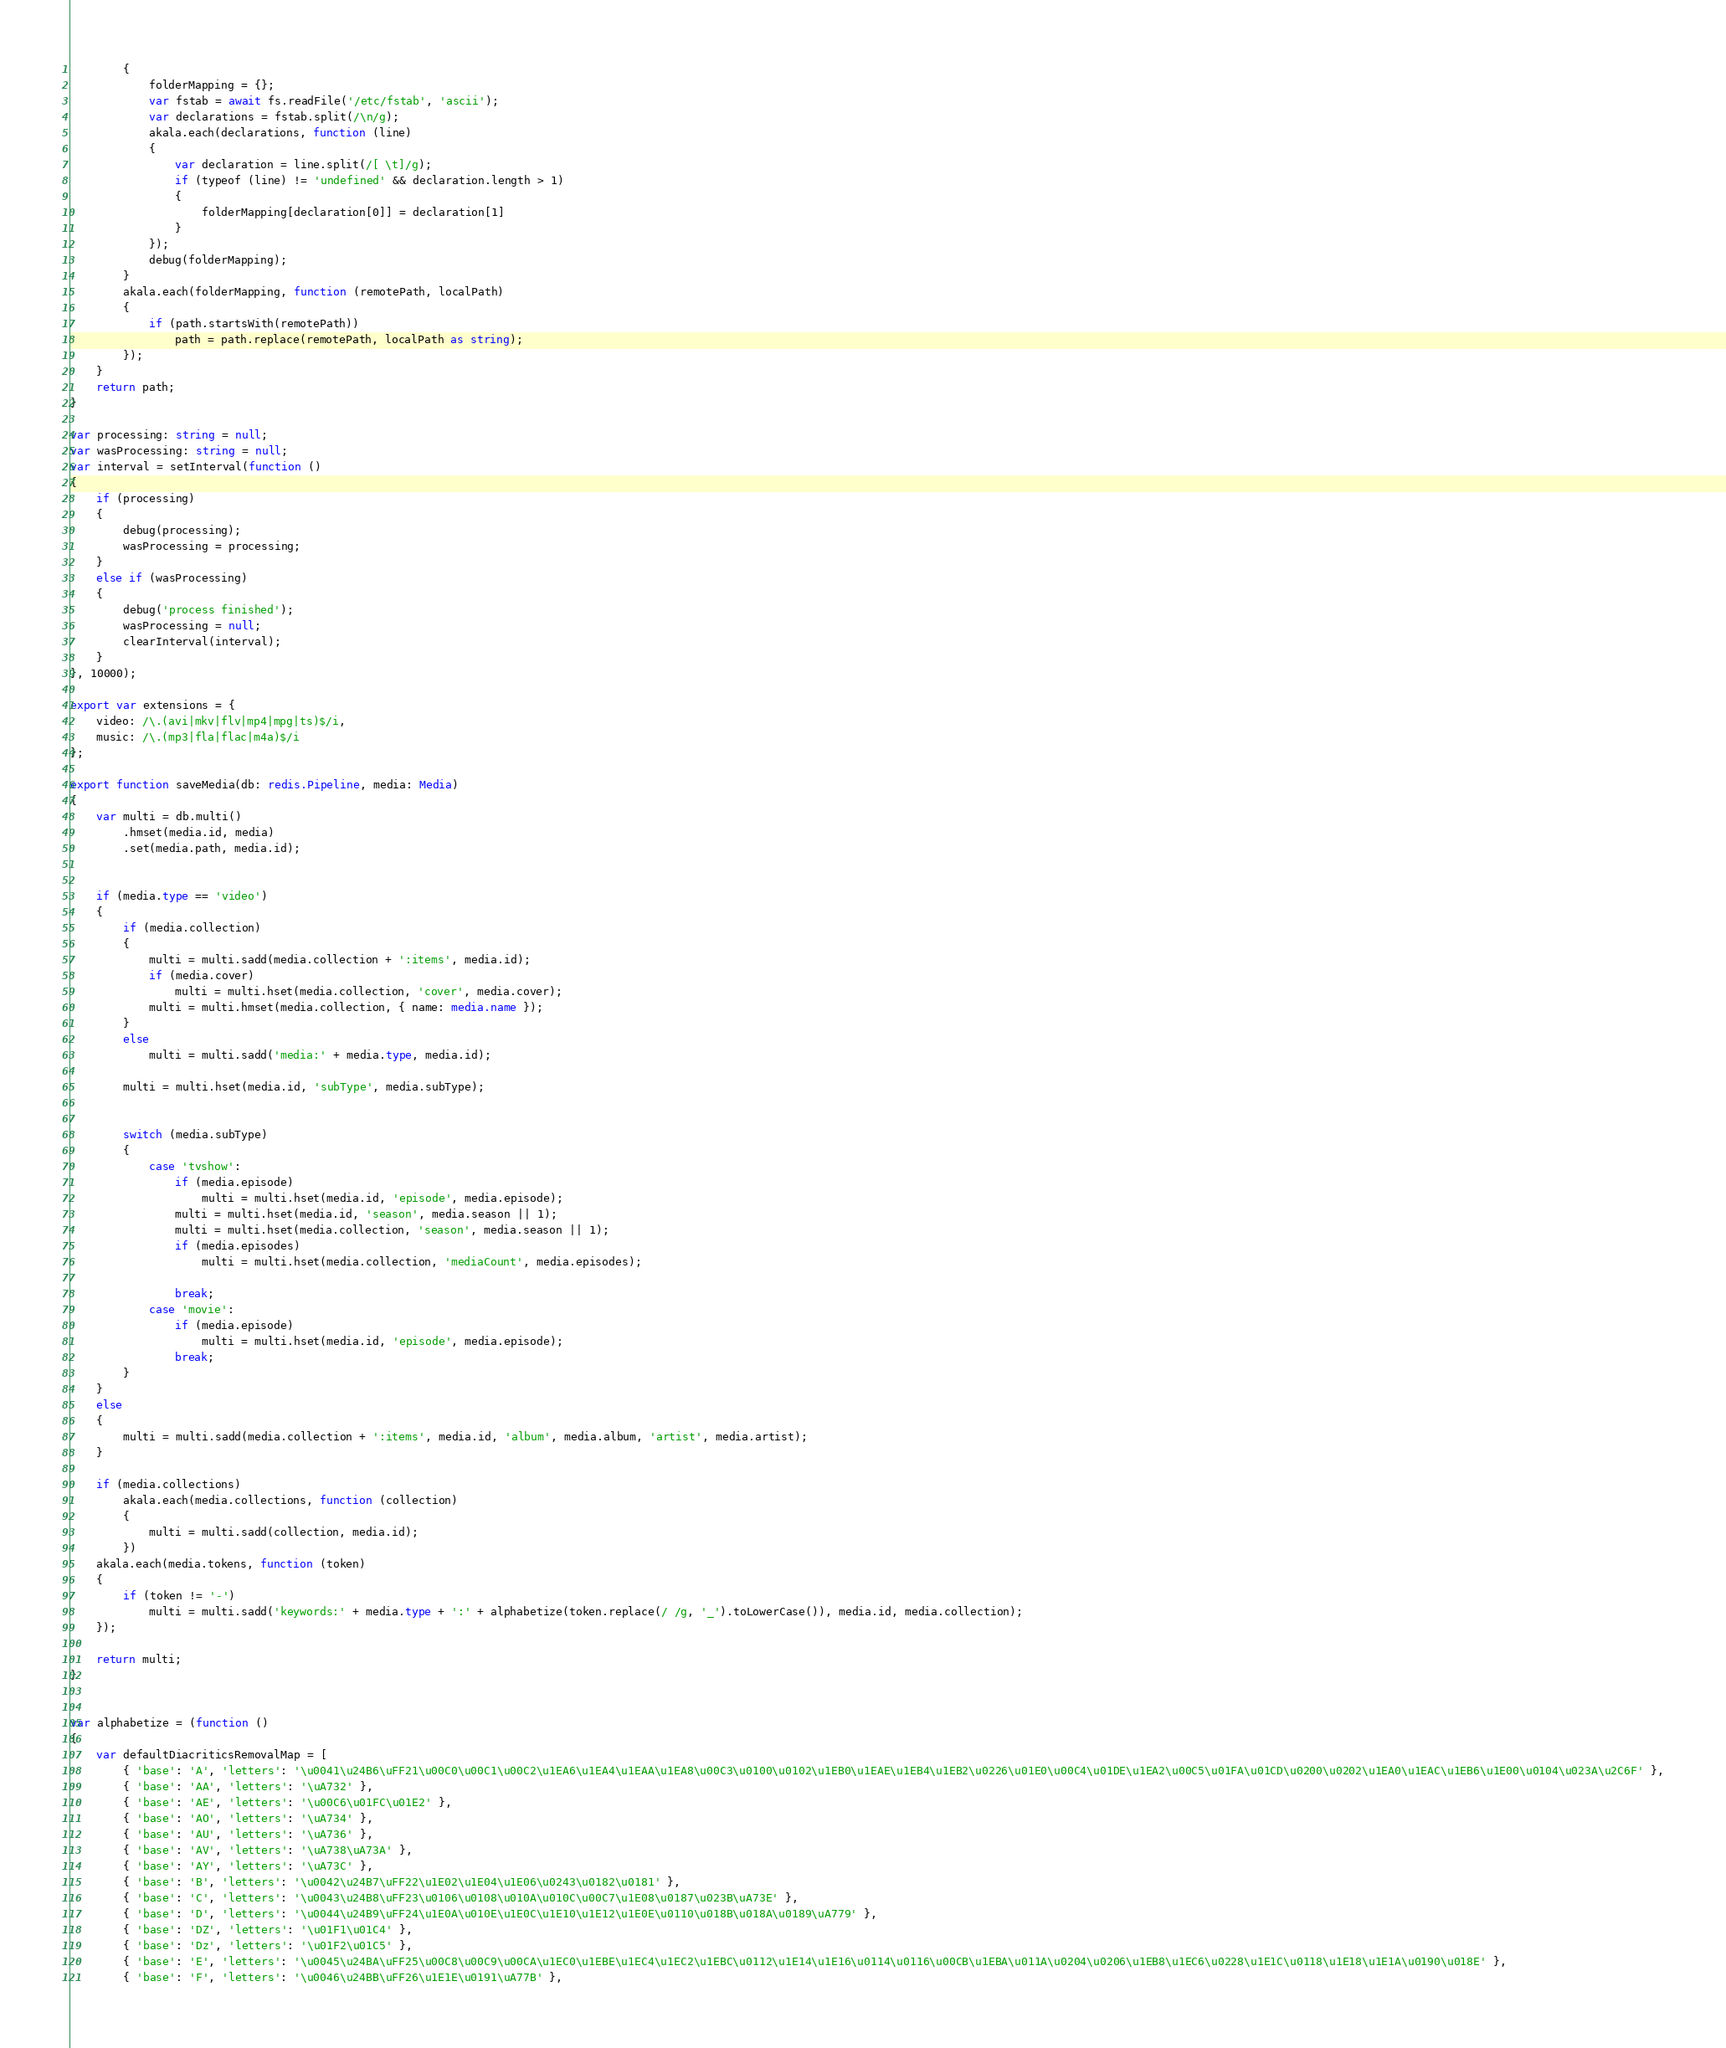Convert code to text. <code><loc_0><loc_0><loc_500><loc_500><_TypeScript_>        {
            folderMapping = {};
            var fstab = await fs.readFile('/etc/fstab', 'ascii');
            var declarations = fstab.split(/\n/g);
            akala.each(declarations, function (line)
            {
                var declaration = line.split(/[ \t]/g);
                if (typeof (line) != 'undefined' && declaration.length > 1)
                {
                    folderMapping[declaration[0]] = declaration[1]
                }
            });
            debug(folderMapping);
        }
        akala.each(folderMapping, function (remotePath, localPath)
        {
            if (path.startsWith(remotePath))
                path = path.replace(remotePath, localPath as string);
        });
    }
    return path;
}

var processing: string = null;
var wasProcessing: string = null;
var interval = setInterval(function ()
{
    if (processing)
    {
        debug(processing);
        wasProcessing = processing;
    }
    else if (wasProcessing)
    {
        debug('process finished');
        wasProcessing = null;
        clearInterval(interval);
    }
}, 10000);

export var extensions = {
    video: /\.(avi|mkv|flv|mp4|mpg|ts)$/i,
    music: /\.(mp3|fla|flac|m4a)$/i
};

export function saveMedia(db: redis.Pipeline, media: Media)
{
    var multi = db.multi()
        .hmset(media.id, media)
        .set(media.path, media.id);


    if (media.type == 'video')
    {
        if (media.collection)
        {
            multi = multi.sadd(media.collection + ':items', media.id);
            if (media.cover)
                multi = multi.hset(media.collection, 'cover', media.cover);
            multi = multi.hmset(media.collection, { name: media.name });
        }
        else
            multi = multi.sadd('media:' + media.type, media.id);

        multi = multi.hset(media.id, 'subType', media.subType);


        switch (media.subType)
        {
            case 'tvshow':
                if (media.episode)
                    multi = multi.hset(media.id, 'episode', media.episode);
                multi = multi.hset(media.id, 'season', media.season || 1);
                multi = multi.hset(media.collection, 'season', media.season || 1);
                if (media.episodes)
                    multi = multi.hset(media.collection, 'mediaCount', media.episodes);

                break;
            case 'movie':
                if (media.episode)
                    multi = multi.hset(media.id, 'episode', media.episode);
                break;
        }
    }
    else
    {
        multi = multi.sadd(media.collection + ':items', media.id, 'album', media.album, 'artist', media.artist);
    }

    if (media.collections)
        akala.each(media.collections, function (collection)
        {
            multi = multi.sadd(collection, media.id);
        })
    akala.each(media.tokens, function (token)
    {
        if (token != '-')
            multi = multi.sadd('keywords:' + media.type + ':' + alphabetize(token.replace(/ /g, '_').toLowerCase()), media.id, media.collection);
    });

    return multi;
}


var alphabetize = (function ()
{
    var defaultDiacriticsRemovalMap = [
        { 'base': 'A', 'letters': '\u0041\u24B6\uFF21\u00C0\u00C1\u00C2\u1EA6\u1EA4\u1EAA\u1EA8\u00C3\u0100\u0102\u1EB0\u1EAE\u1EB4\u1EB2\u0226\u01E0\u00C4\u01DE\u1EA2\u00C5\u01FA\u01CD\u0200\u0202\u1EA0\u1EAC\u1EB6\u1E00\u0104\u023A\u2C6F' },
        { 'base': 'AA', 'letters': '\uA732' },
        { 'base': 'AE', 'letters': '\u00C6\u01FC\u01E2' },
        { 'base': 'AO', 'letters': '\uA734' },
        { 'base': 'AU', 'letters': '\uA736' },
        { 'base': 'AV', 'letters': '\uA738\uA73A' },
        { 'base': 'AY', 'letters': '\uA73C' },
        { 'base': 'B', 'letters': '\u0042\u24B7\uFF22\u1E02\u1E04\u1E06\u0243\u0182\u0181' },
        { 'base': 'C', 'letters': '\u0043\u24B8\uFF23\u0106\u0108\u010A\u010C\u00C7\u1E08\u0187\u023B\uA73E' },
        { 'base': 'D', 'letters': '\u0044\u24B9\uFF24\u1E0A\u010E\u1E0C\u1E10\u1E12\u1E0E\u0110\u018B\u018A\u0189\uA779' },
        { 'base': 'DZ', 'letters': '\u01F1\u01C4' },
        { 'base': 'Dz', 'letters': '\u01F2\u01C5' },
        { 'base': 'E', 'letters': '\u0045\u24BA\uFF25\u00C8\u00C9\u00CA\u1EC0\u1EBE\u1EC4\u1EC2\u1EBC\u0112\u1E14\u1E16\u0114\u0116\u00CB\u1EBA\u011A\u0204\u0206\u1EB8\u1EC6\u0228\u1E1C\u0118\u1E18\u1E1A\u0190\u018E' },
        { 'base': 'F', 'letters': '\u0046\u24BB\uFF26\u1E1E\u0191\uA77B' },</code> 